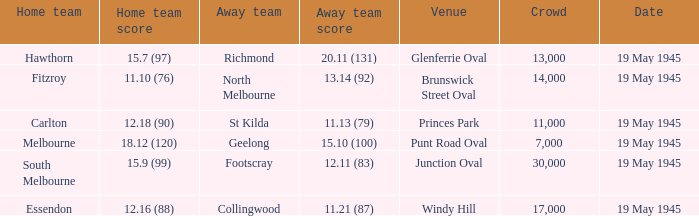On which date was Essendon the home team? 19 May 1945. 